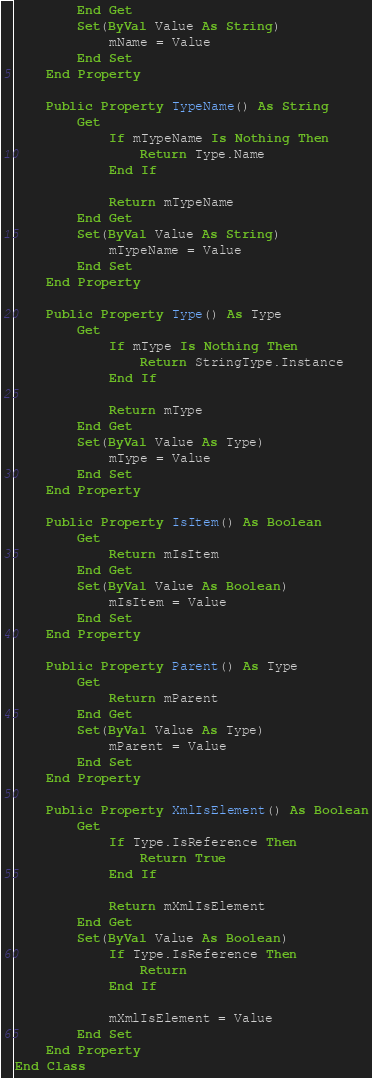<code> <loc_0><loc_0><loc_500><loc_500><_VisualBasic_>        End Get
        Set(ByVal Value As String)
            mName = Value
        End Set
    End Property

    Public Property TypeName() As String
        Get
            If mTypeName Is Nothing Then
                Return Type.Name
            End If

            Return mTypeName
        End Get
        Set(ByVal Value As String)
            mTypeName = Value
        End Set
    End Property

    Public Property Type() As Type
        Get
            If mType Is Nothing Then
                Return StringType.Instance
            End If

            Return mType
        End Get
        Set(ByVal Value As Type)
            mType = Value
        End Set
    End Property

    Public Property IsItem() As Boolean
        Get
            Return mIsItem
        End Get
        Set(ByVal Value As Boolean)
            mIsItem = Value
        End Set
    End Property

    Public Property Parent() As Type
        Get
            Return mParent
        End Get
        Set(ByVal Value As Type)
            mParent = Value
        End Set
    End Property

    Public Property XmlIsElement() As Boolean
        Get
            If Type.IsReference Then
                Return True
            End If

            Return mXmlIsElement
        End Get
        Set(ByVal Value As Boolean)
            If Type.IsReference Then
                Return
            End If

            mXmlIsElement = Value
        End Set
    End Property
End Class
</code> 